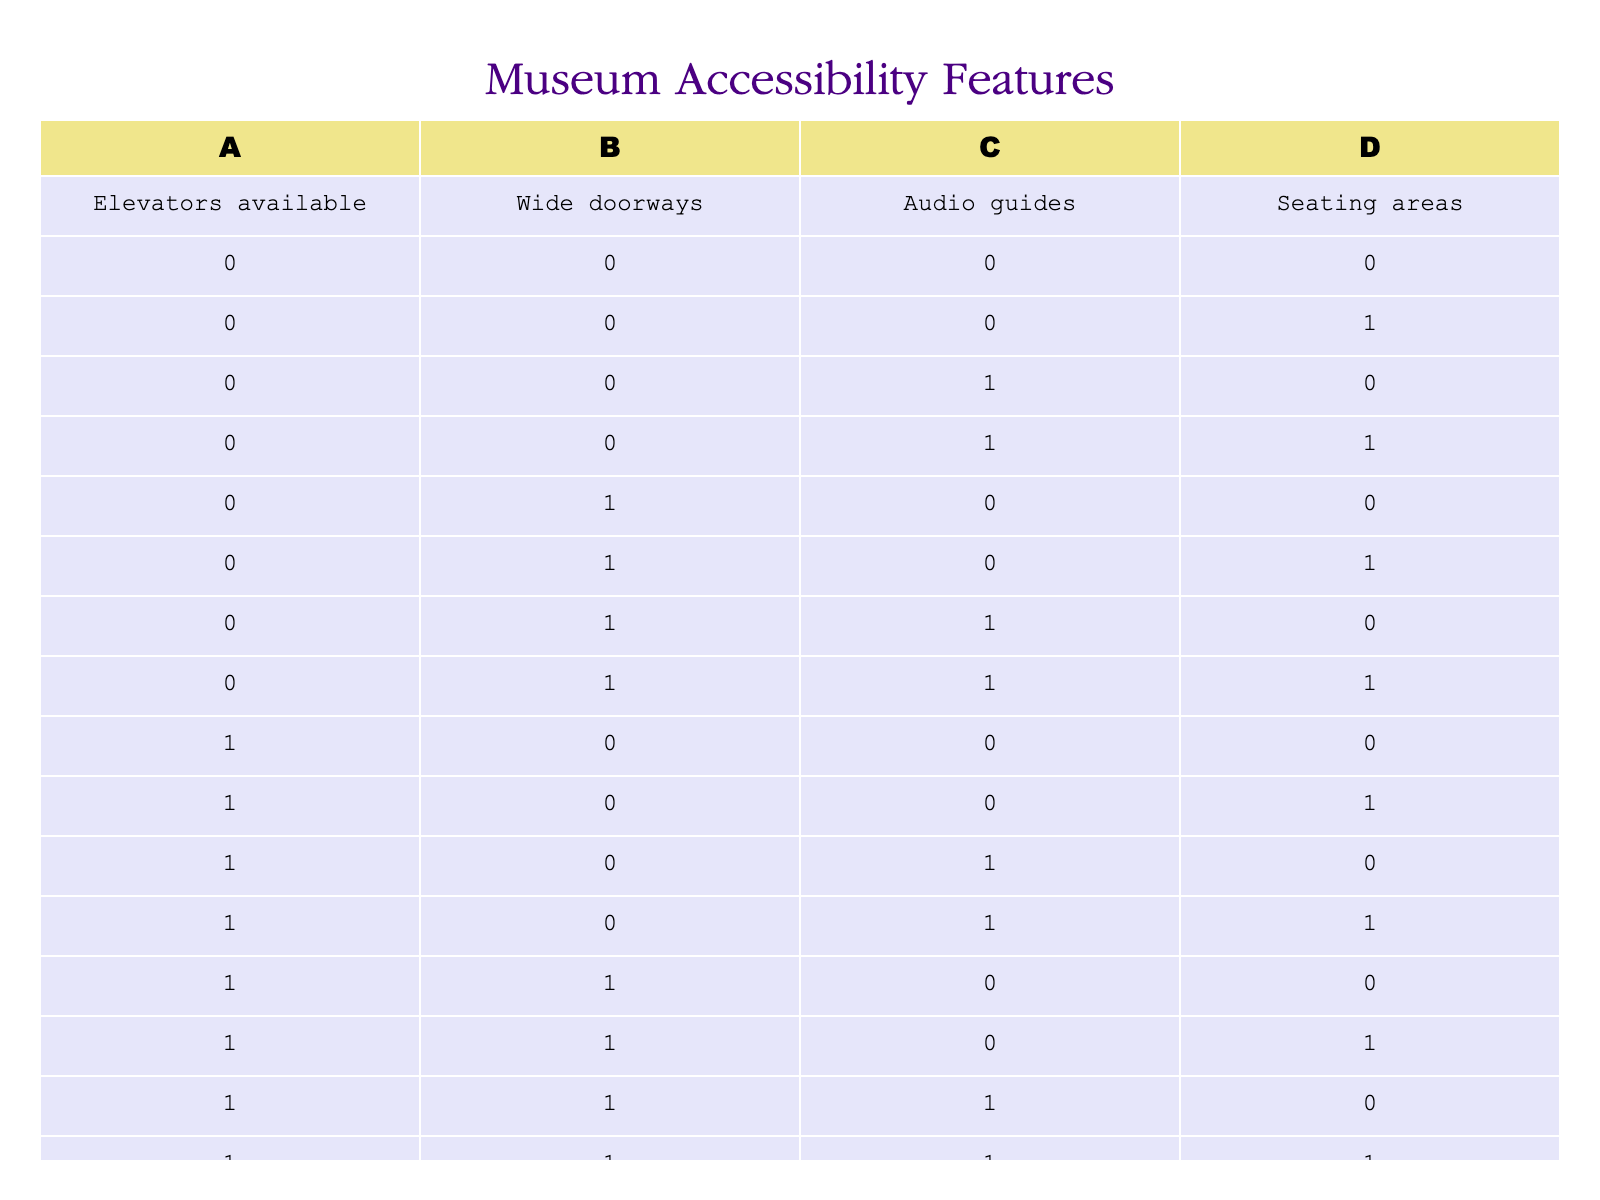What is the total number of rows where elevators are available? There are 8 rows where the value for elevators available (A) is 1, which can be identified by counting the occurrences of 1 in that column.
Answer: 8 How many combinations include both wide doorways and audio guides? To find the combinations that have both wide doorways (B) and audio guides (C) as 1, we look for rows where both B and C are 1. In the table, there are 3 such combinations.
Answer: 3 Is there at least one entry where all accessibility features are available? We identify if there's a row where all four features (A, B, C, D) show 1. The last row in the table has 1 for A, B, C, and D, confirming the presence of all features.
Answer: Yes What percentage of entries provide seating areas? Out of 16 total entries, 8 entries have seating areas (D) as 1. To find the percentage, we calculate (8/16) * 100 which gives us 50%.
Answer: 50% How many rows have either elevators or audio guides available? We need to count the number of rows where either A or C is 1. A quick check shows that there are 10 such rows (combining rows where A is 1 with those where C is 1 and making sure not to double count).
Answer: 10 Which combination of features has the most entries? To determine the combination with the most entries, we compare the counts of each unique combination across the four features. The combination with all features available (A=1, B=1, C=1, D=1) has 1 entry, but the combination with elevators, wide doorways, and audio guides (A=1, B=1, C=1, D=0) has 1 entry. Many combinations have fewer than these two.
Answer: 4 combinations (e.g., elevators available with audio guides but no wide doorways or seating) Are there any entries where wide doorways are available but seating areas are not? We check for rows where B is 1 and D is 0. After examining the table, we find one such entry where this condition holds true.
Answer: Yes What is the average number of accessibility features available in the table? Each row in the table represents a combination of accessibility features. We count the total number of features across all combinations (which is 49) and divide by the number of rows (16) to find the average. 49/16 results in an average of approximately 3.06 features per entry.
Answer: 3.06 How many entries offer both seating areas and audio guides? We see how many rows have D and C both equal to 1. After checking the table, we find that there are 4 entries meeting this criterion.
Answer: 4 